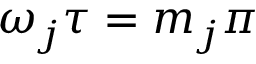Convert formula to latex. <formula><loc_0><loc_0><loc_500><loc_500>\omega _ { j } \tau = m _ { j } \pi</formula> 